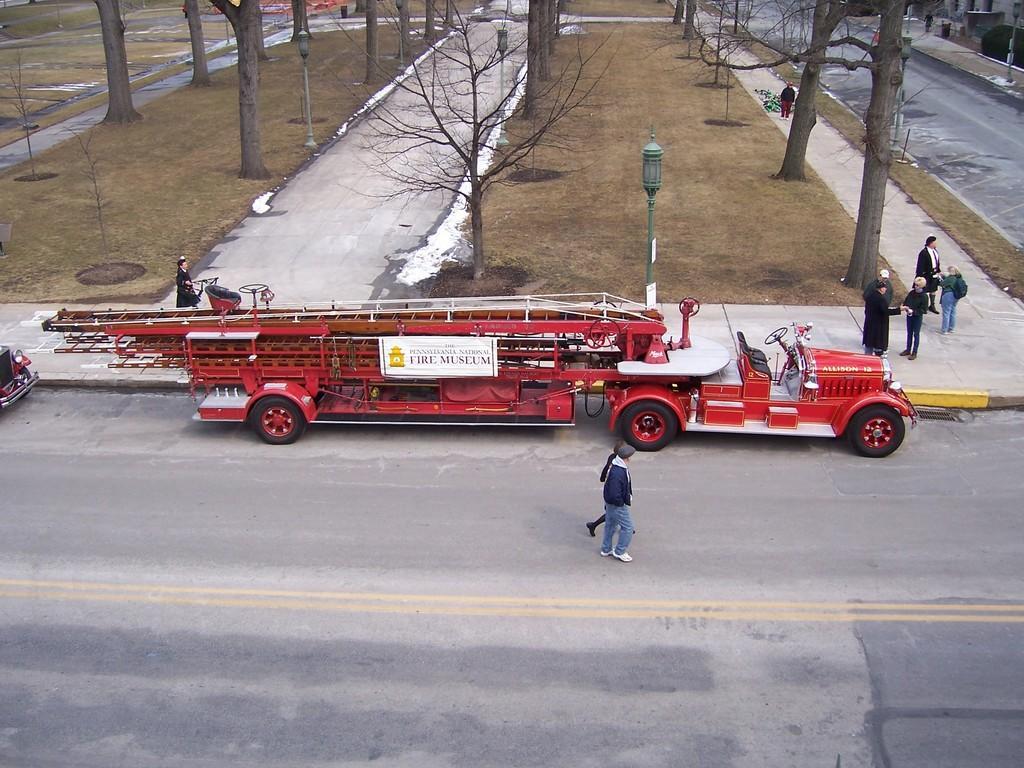Please provide a concise description of this image. In this image in the center there are persons walking. There are vehicles and there are persons standing. In the background there are trees and there is a pole in the center. On the right side there are plants and there is a building. 